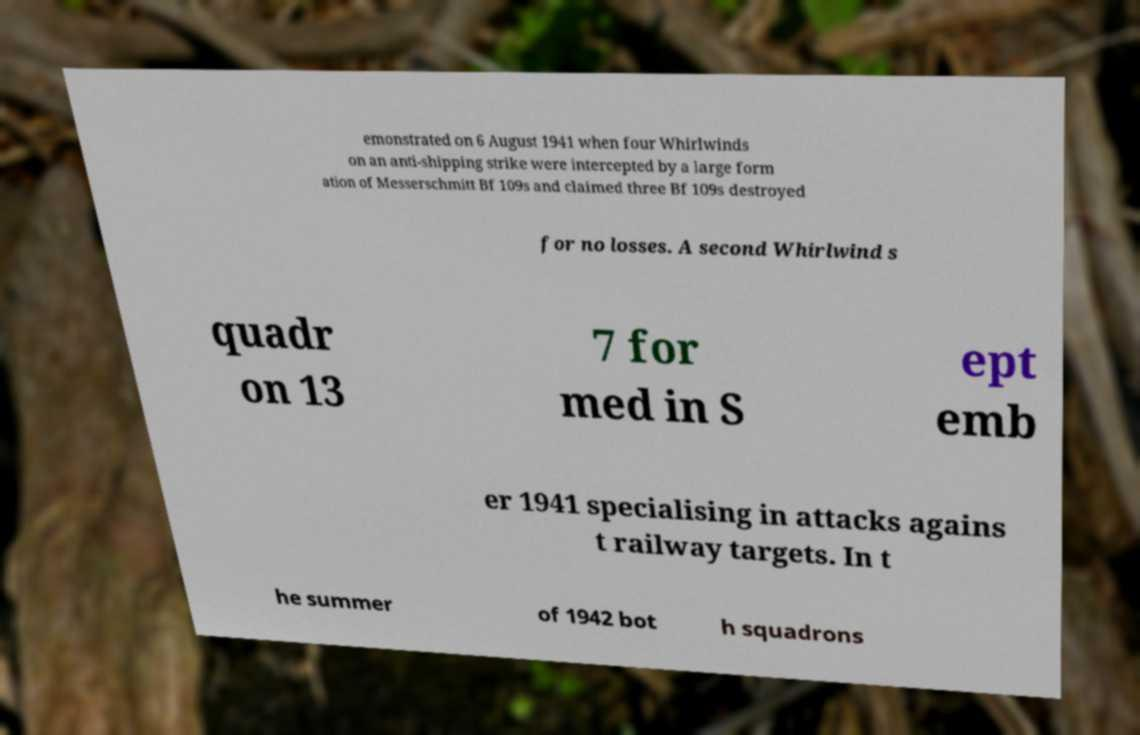What messages or text are displayed in this image? I need them in a readable, typed format. emonstrated on 6 August 1941 when four Whirlwinds on an anti-shipping strike were intercepted by a large form ation of Messerschmitt Bf 109s and claimed three Bf 109s destroyed for no losses. A second Whirlwind s quadr on 13 7 for med in S ept emb er 1941 specialising in attacks agains t railway targets. In t he summer of 1942 bot h squadrons 